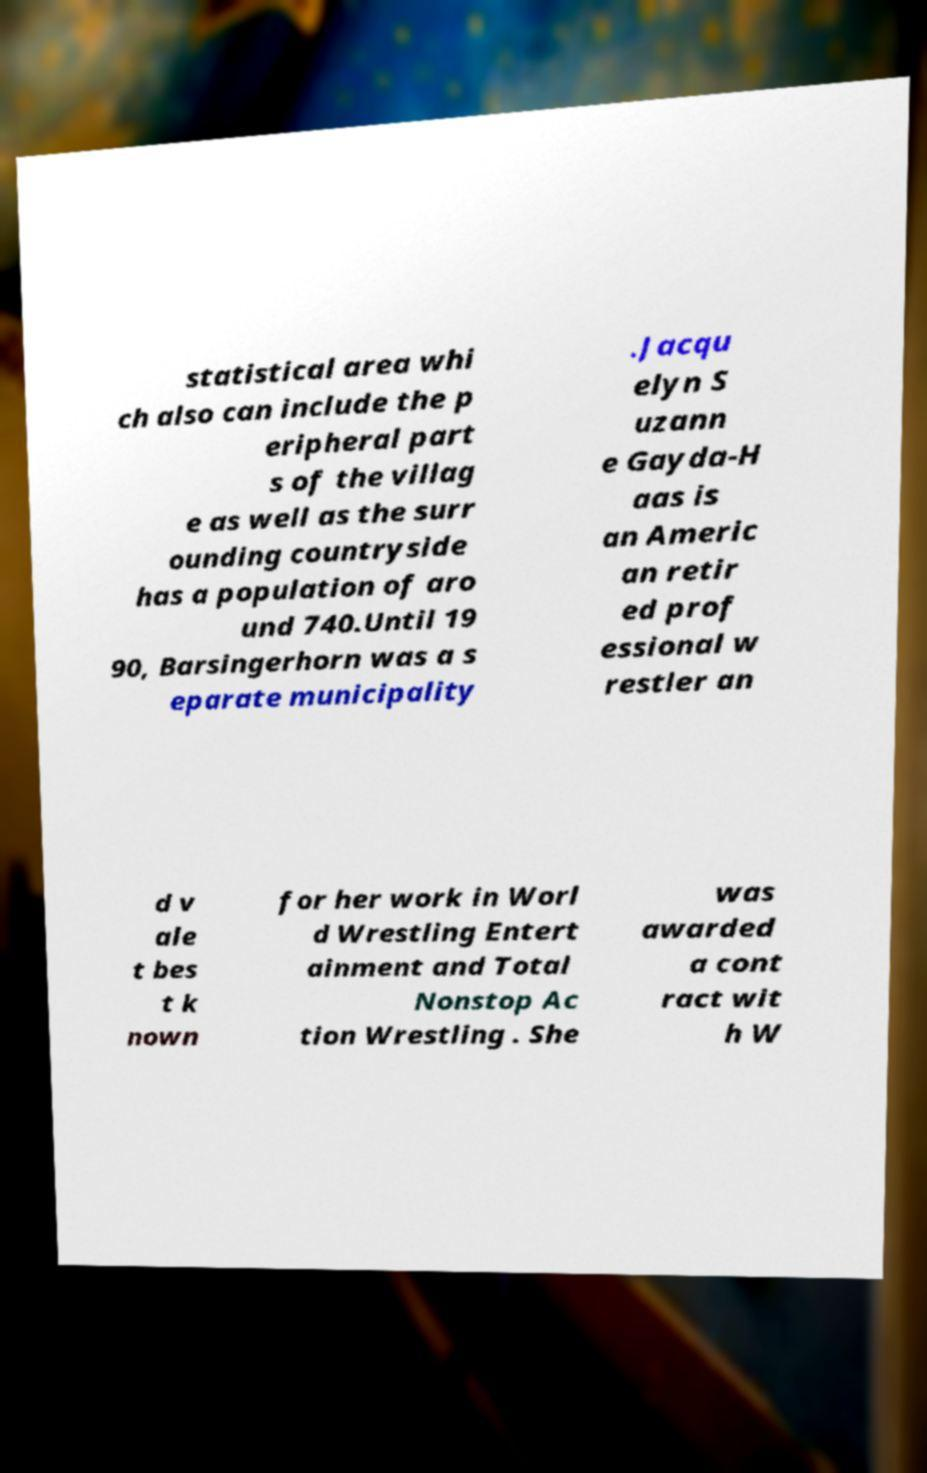I need the written content from this picture converted into text. Can you do that? statistical area whi ch also can include the p eripheral part s of the villag e as well as the surr ounding countryside has a population of aro und 740.Until 19 90, Barsingerhorn was a s eparate municipality .Jacqu elyn S uzann e Gayda-H aas is an Americ an retir ed prof essional w restler an d v ale t bes t k nown for her work in Worl d Wrestling Entert ainment and Total Nonstop Ac tion Wrestling . She was awarded a cont ract wit h W 